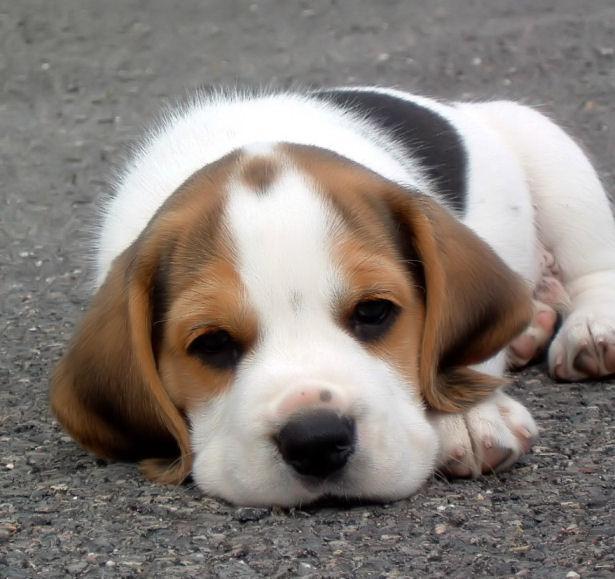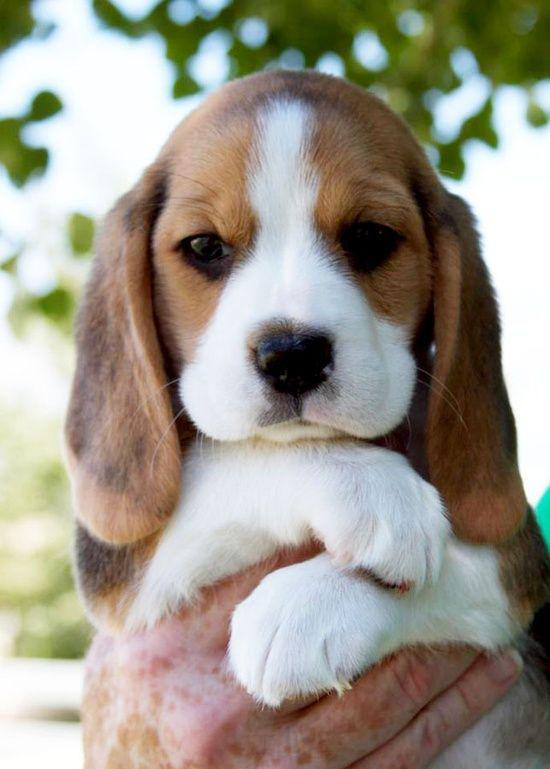The first image is the image on the left, the second image is the image on the right. Considering the images on both sides, is "The image on the right shows at least one beagle puppy held by a human hand." valid? Answer yes or no. Yes. The first image is the image on the left, the second image is the image on the right. Considering the images on both sides, is "there is a beagle puppy lying belly down in the image to the left" valid? Answer yes or no. Yes. 